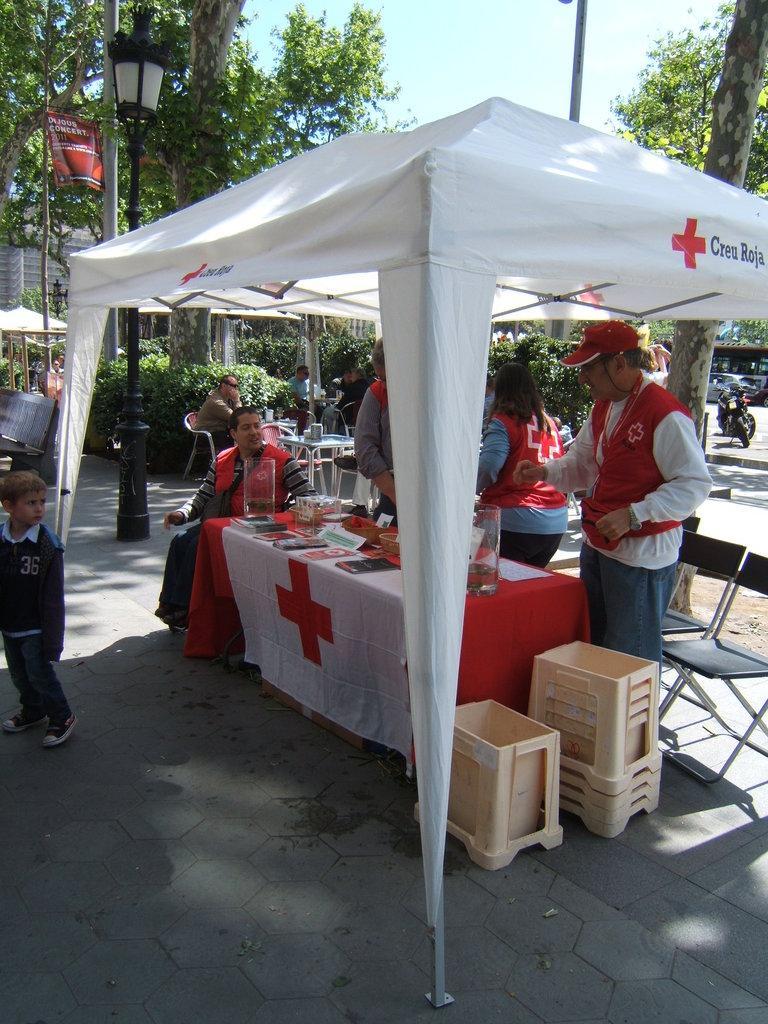Can you describe this image briefly? This picture describes about group of people few are seated on the chair and few are standing, in front of them we can see glasses, jugs, books on the table, and also we can see a tent, couple of boxes, chairs, lights, buildings and trees. 